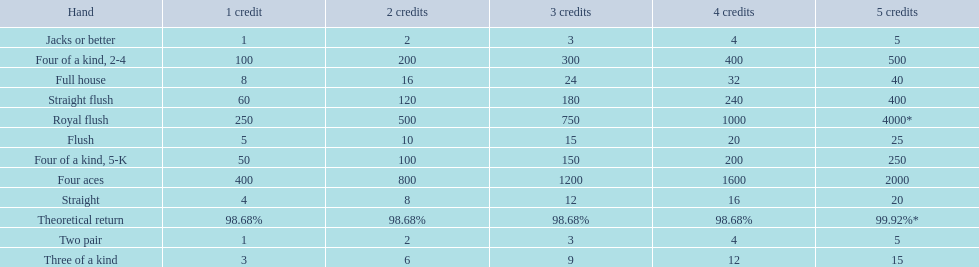What are the hands in super aces? Royal flush, Straight flush, Four aces, Four of a kind, 2-4, Four of a kind, 5-K, Full house, Flush, Straight, Three of a kind, Two pair, Jacks or better. What hand gives the highest credits? Royal flush. 